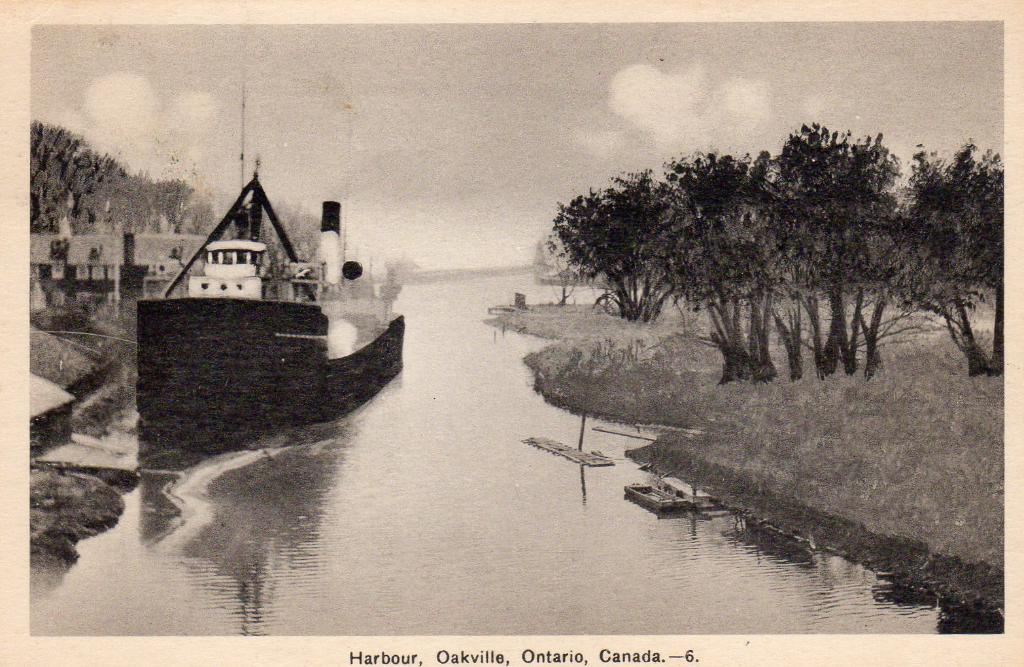Provide a one-sentence caption for the provided image. Postcard showing a boat by a body of a body of river in Ontario, Canada. 